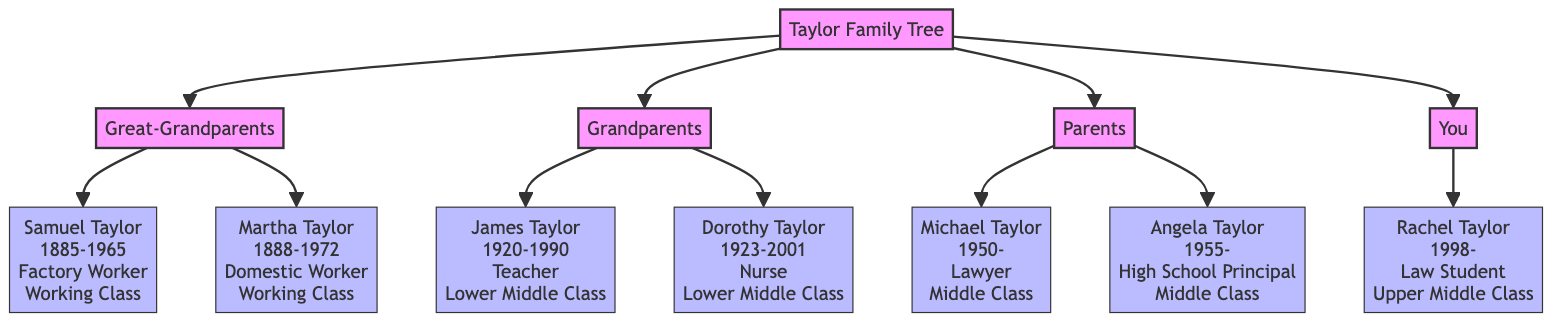What migration pattern did Samuel and Martha Taylor have? Both Samuel and Martha Taylor migrated from Mississippi to Chicago during the Great Migration as indicated in their respective entries in the diagram.
Answer: Migrated from Mississippi to Chicago during the Great Migration Who is the only member of the "You" generation? The diagram shows only one member in the "You" generation, Rachel Taylor, as indicated in the section that details each member's information.
Answer: Rachel Taylor What was the socio-economic status of James Taylor? The diagram specifies that James Taylor's socio-economic status is "Lower Middle Class," which is noted directly in his individual member entry.
Answer: Lower Middle Class How many generations are represented in the Taylor family tree? The diagram displays a total of four generations: Great-Grandparents, Grandparents, Parents, and You, which can be counted from the branching structure.
Answer: 4 What was the occupation of Angela Taylor? According to the diagram, Angela Taylor is listed as a "High School Principal," which is immediately available next to her name in the diagram.
Answer: High School Principal How did the socio-economic status change from the Great-Grandparents to the Parents? The socio-economic status of the Great-Grandparents was "Working Class," while that of the Parents was "Middle Class," indicating an upward shift in status over the generations.
Answer: Upward shift Which generation has members with the highest socio-economic status? The diagram indicates that the "You" generation has the highest socio-economic status listed, with Rachel Taylor being "Upper Middle Class."
Answer: You What is the birth year of Dorothy Taylor? The diagram clearly states that Dorothy Taylor was born in 1923, which is included in her member information.
Answer: 1923 What is Rachel Taylor's current occupation? The diagram identifies Rachel Taylor's occupation as "Law Student," which is prominently displayed alongside her name in the diagram.
Answer: Law Student 